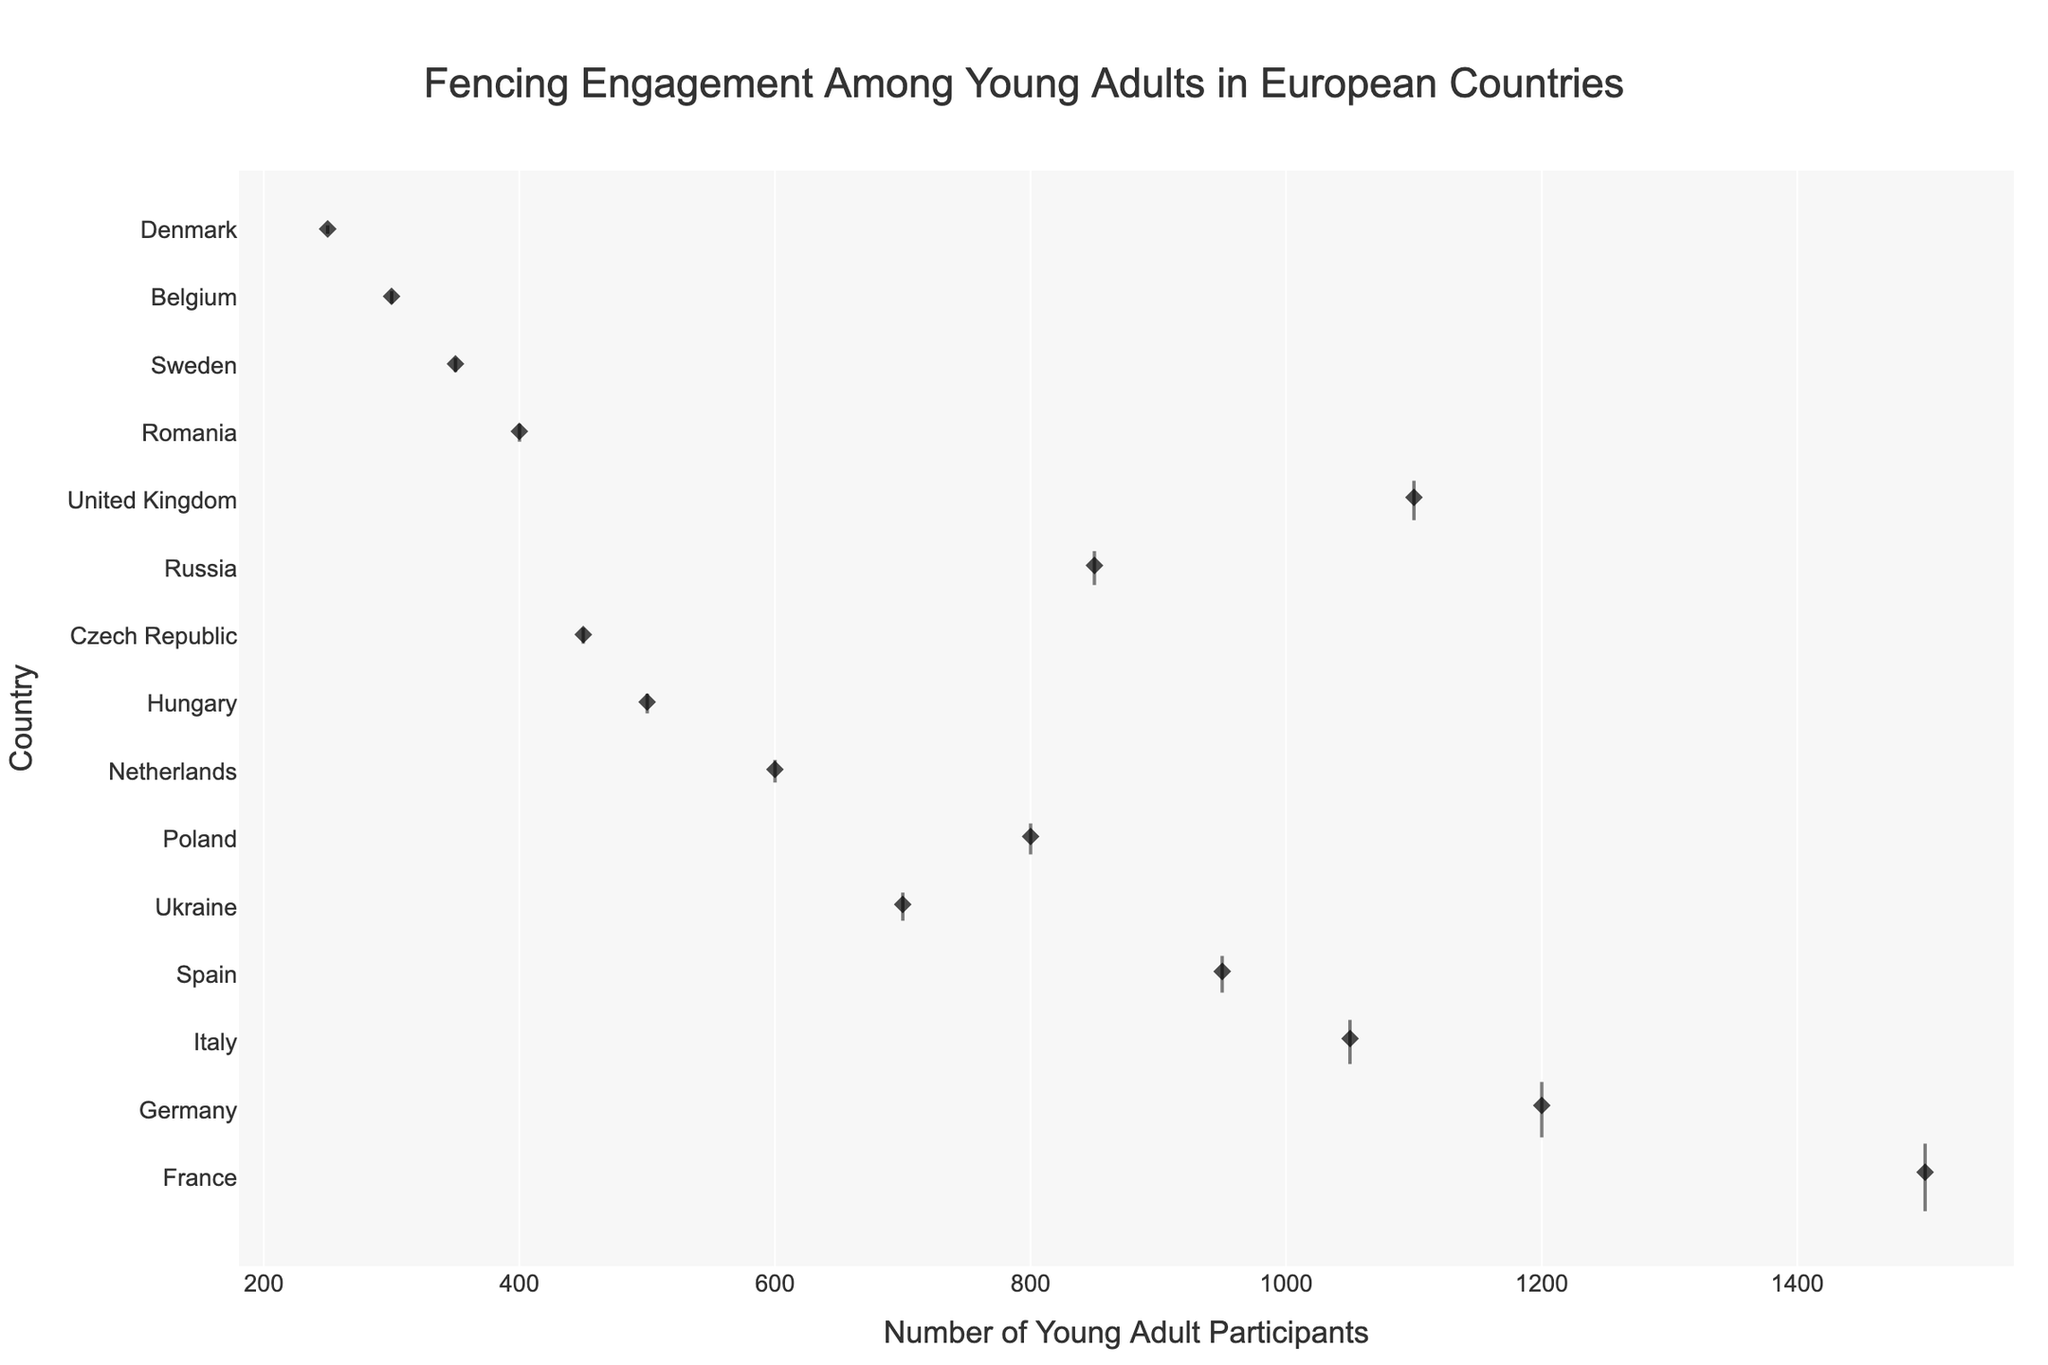Which country has the highest engagement level? The color corresponding to the highest engagement level is green. France and the United Kingdom have green boxes indicating high engagement levels.
Answer: France and the United Kingdom What is the range of young adult participants across all countries? The x-axis represents the number of young adult participants. The maximum is 1500 (France), and the minimum is 250 (Denmark). Therefore, the range is 1500 - 250 = 1250.
Answer: 1250 Which country has the widest box width? The width of the boxes is proportional to the number of clubs in each country. France, with 120 clubs, has the widest box.
Answer: France Which countries have medium engagement levels? The color corresponding to medium engagement levels is blue. Germany, Italy, Ukraine, Poland, Hungary, and Russia have blue boxes.
Answer: Germany, Italy, Ukraine, Poland, Hungary, and Russia How many countries have low engagement levels? The color corresponding to low engagement levels is red. There are eight red boxes indicating low engagement levels.
Answer: Eight Is there a country with more clubs than young adult participants? No country has a higher number of clubs compared to its young adult participants since the number of clubs ranges from 15 to 120, while participants range from 250 to 1500.
Answer: No What is the average number of young adult participants in countries with high engagement levels? High engagement level is found in France (1500) and the United Kingdom (1100). The sum is 1500 + 1100 = 2600, and there are two countries, so 2600 / 2 = 1300.
Answer: 1300 Which country has a higher number of young adult participants, Ukraine or Poland? From the plot, Ukraine has 700 participants, and Poland has 800. Hence, Poland has a higher number.
Answer: Poland 